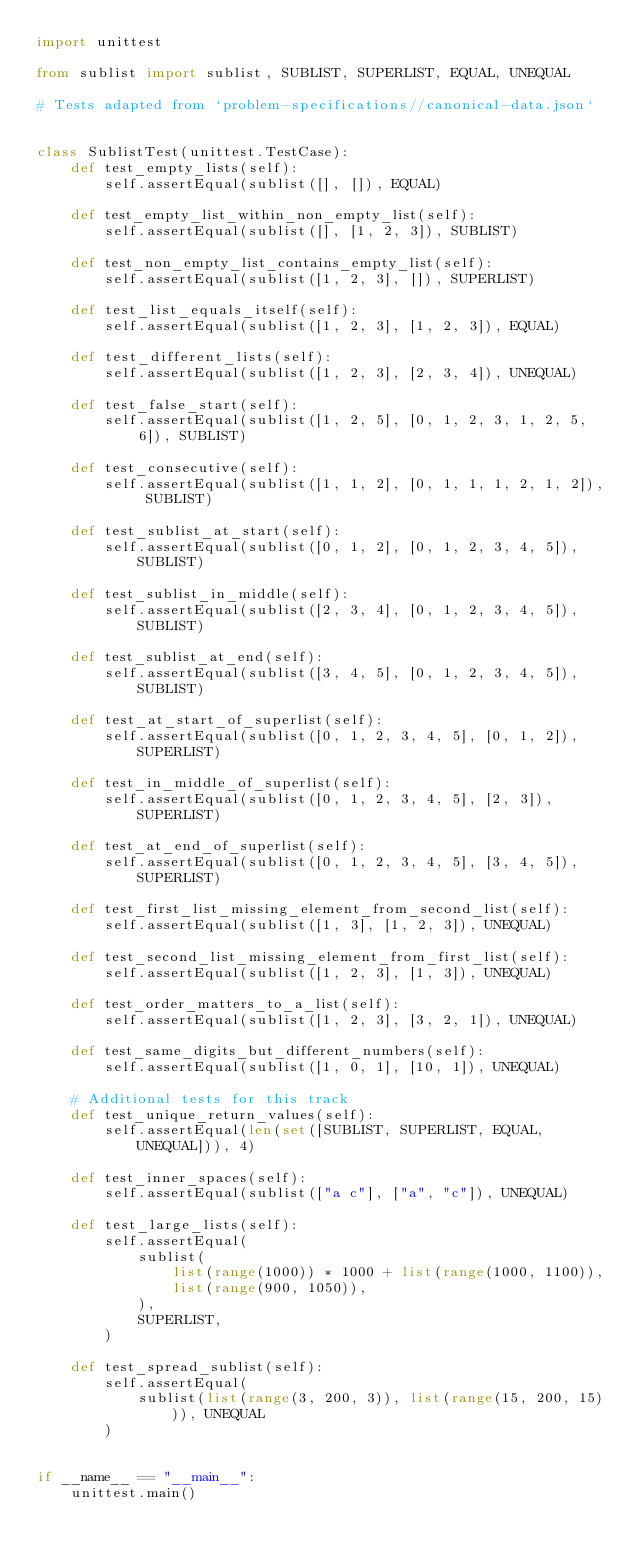Convert code to text. <code><loc_0><loc_0><loc_500><loc_500><_Python_>import unittest

from sublist import sublist, SUBLIST, SUPERLIST, EQUAL, UNEQUAL

# Tests adapted from `problem-specifications//canonical-data.json`


class SublistTest(unittest.TestCase):
    def test_empty_lists(self):
        self.assertEqual(sublist([], []), EQUAL)

    def test_empty_list_within_non_empty_list(self):
        self.assertEqual(sublist([], [1, 2, 3]), SUBLIST)

    def test_non_empty_list_contains_empty_list(self):
        self.assertEqual(sublist([1, 2, 3], []), SUPERLIST)

    def test_list_equals_itself(self):
        self.assertEqual(sublist([1, 2, 3], [1, 2, 3]), EQUAL)

    def test_different_lists(self):
        self.assertEqual(sublist([1, 2, 3], [2, 3, 4]), UNEQUAL)

    def test_false_start(self):
        self.assertEqual(sublist([1, 2, 5], [0, 1, 2, 3, 1, 2, 5, 6]), SUBLIST)

    def test_consecutive(self):
        self.assertEqual(sublist([1, 1, 2], [0, 1, 1, 1, 2, 1, 2]), SUBLIST)

    def test_sublist_at_start(self):
        self.assertEqual(sublist([0, 1, 2], [0, 1, 2, 3, 4, 5]), SUBLIST)

    def test_sublist_in_middle(self):
        self.assertEqual(sublist([2, 3, 4], [0, 1, 2, 3, 4, 5]), SUBLIST)

    def test_sublist_at_end(self):
        self.assertEqual(sublist([3, 4, 5], [0, 1, 2, 3, 4, 5]), SUBLIST)

    def test_at_start_of_superlist(self):
        self.assertEqual(sublist([0, 1, 2, 3, 4, 5], [0, 1, 2]), SUPERLIST)

    def test_in_middle_of_superlist(self):
        self.assertEqual(sublist([0, 1, 2, 3, 4, 5], [2, 3]), SUPERLIST)

    def test_at_end_of_superlist(self):
        self.assertEqual(sublist([0, 1, 2, 3, 4, 5], [3, 4, 5]), SUPERLIST)

    def test_first_list_missing_element_from_second_list(self):
        self.assertEqual(sublist([1, 3], [1, 2, 3]), UNEQUAL)

    def test_second_list_missing_element_from_first_list(self):
        self.assertEqual(sublist([1, 2, 3], [1, 3]), UNEQUAL)

    def test_order_matters_to_a_list(self):
        self.assertEqual(sublist([1, 2, 3], [3, 2, 1]), UNEQUAL)

    def test_same_digits_but_different_numbers(self):
        self.assertEqual(sublist([1, 0, 1], [10, 1]), UNEQUAL)

    # Additional tests for this track
    def test_unique_return_values(self):
        self.assertEqual(len(set([SUBLIST, SUPERLIST, EQUAL, UNEQUAL])), 4)

    def test_inner_spaces(self):
        self.assertEqual(sublist(["a c"], ["a", "c"]), UNEQUAL)

    def test_large_lists(self):
        self.assertEqual(
            sublist(
                list(range(1000)) * 1000 + list(range(1000, 1100)),
                list(range(900, 1050)),
            ),
            SUPERLIST,
        )

    def test_spread_sublist(self):
        self.assertEqual(
            sublist(list(range(3, 200, 3)), list(range(15, 200, 15))), UNEQUAL
        )


if __name__ == "__main__":
    unittest.main()
</code> 